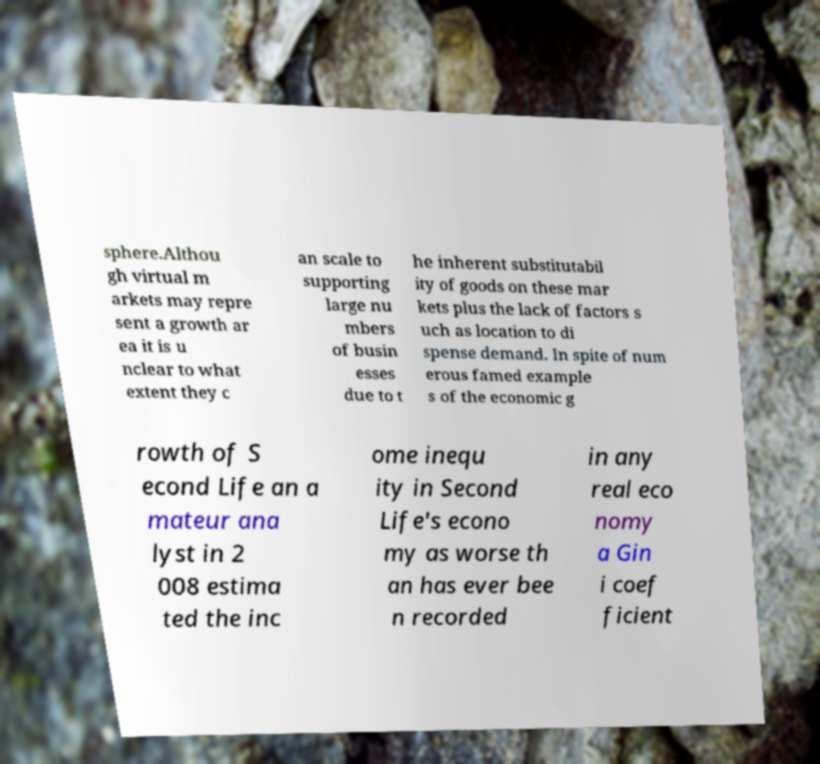For documentation purposes, I need the text within this image transcribed. Could you provide that? sphere.Althou gh virtual m arkets may repre sent a growth ar ea it is u nclear to what extent they c an scale to supporting large nu mbers of busin esses due to t he inherent substitutabil ity of goods on these mar kets plus the lack of factors s uch as location to di spense demand. In spite of num erous famed example s of the economic g rowth of S econd Life an a mateur ana lyst in 2 008 estima ted the inc ome inequ ity in Second Life's econo my as worse th an has ever bee n recorded in any real eco nomy a Gin i coef ficient 